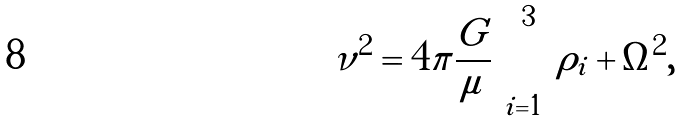<formula> <loc_0><loc_0><loc_500><loc_500>\nu ^ { 2 } = 4 \pi \frac { G } { \mu } \sum _ { i = 1 } ^ { 3 } \rho _ { i } + \Omega ^ { 2 } ,</formula> 